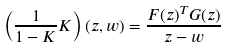Convert formula to latex. <formula><loc_0><loc_0><loc_500><loc_500>\left ( \frac { 1 } { 1 - K } K \right ) ( z , w ) = \frac { F ( z ) ^ { T } G ( z ) } { z - w }</formula> 